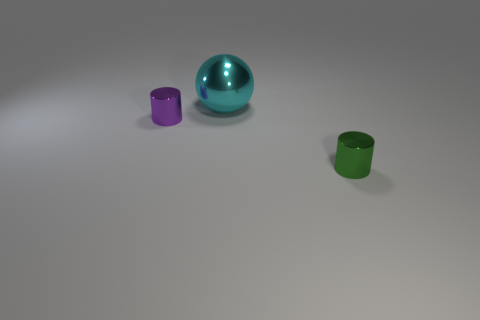The ball that is made of the same material as the green thing is what size?
Your response must be concise. Large. What is the size of the other shiny thing that is the same shape as the purple shiny object?
Provide a short and direct response. Small. Is there a gray matte cylinder?
Offer a very short reply. No. What color is the other thing that is the same shape as the purple metal thing?
Your answer should be compact. Green. Does the cyan object have the same size as the purple cylinder?
Your response must be concise. No. The large cyan object that is the same material as the tiny green cylinder is what shape?
Provide a succinct answer. Sphere. How many other things are there of the same shape as the purple object?
Make the answer very short. 1. The small thing that is to the right of the tiny metal object on the left side of the big cyan thing that is behind the green metallic thing is what shape?
Provide a short and direct response. Cylinder. What number of cylinders are either red matte objects or large cyan metallic objects?
Keep it short and to the point. 0. Are there any cyan metallic objects that are behind the tiny cylinder that is on the left side of the cyan shiny thing?
Your answer should be compact. Yes. 